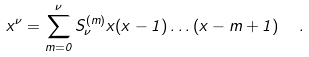Convert formula to latex. <formula><loc_0><loc_0><loc_500><loc_500>x ^ { \nu } = \sum _ { m = 0 } ^ { \nu } { S } ^ { ( m ) } _ { \nu } x ( x - 1 ) \dots ( x - m + 1 ) \ \ .</formula> 